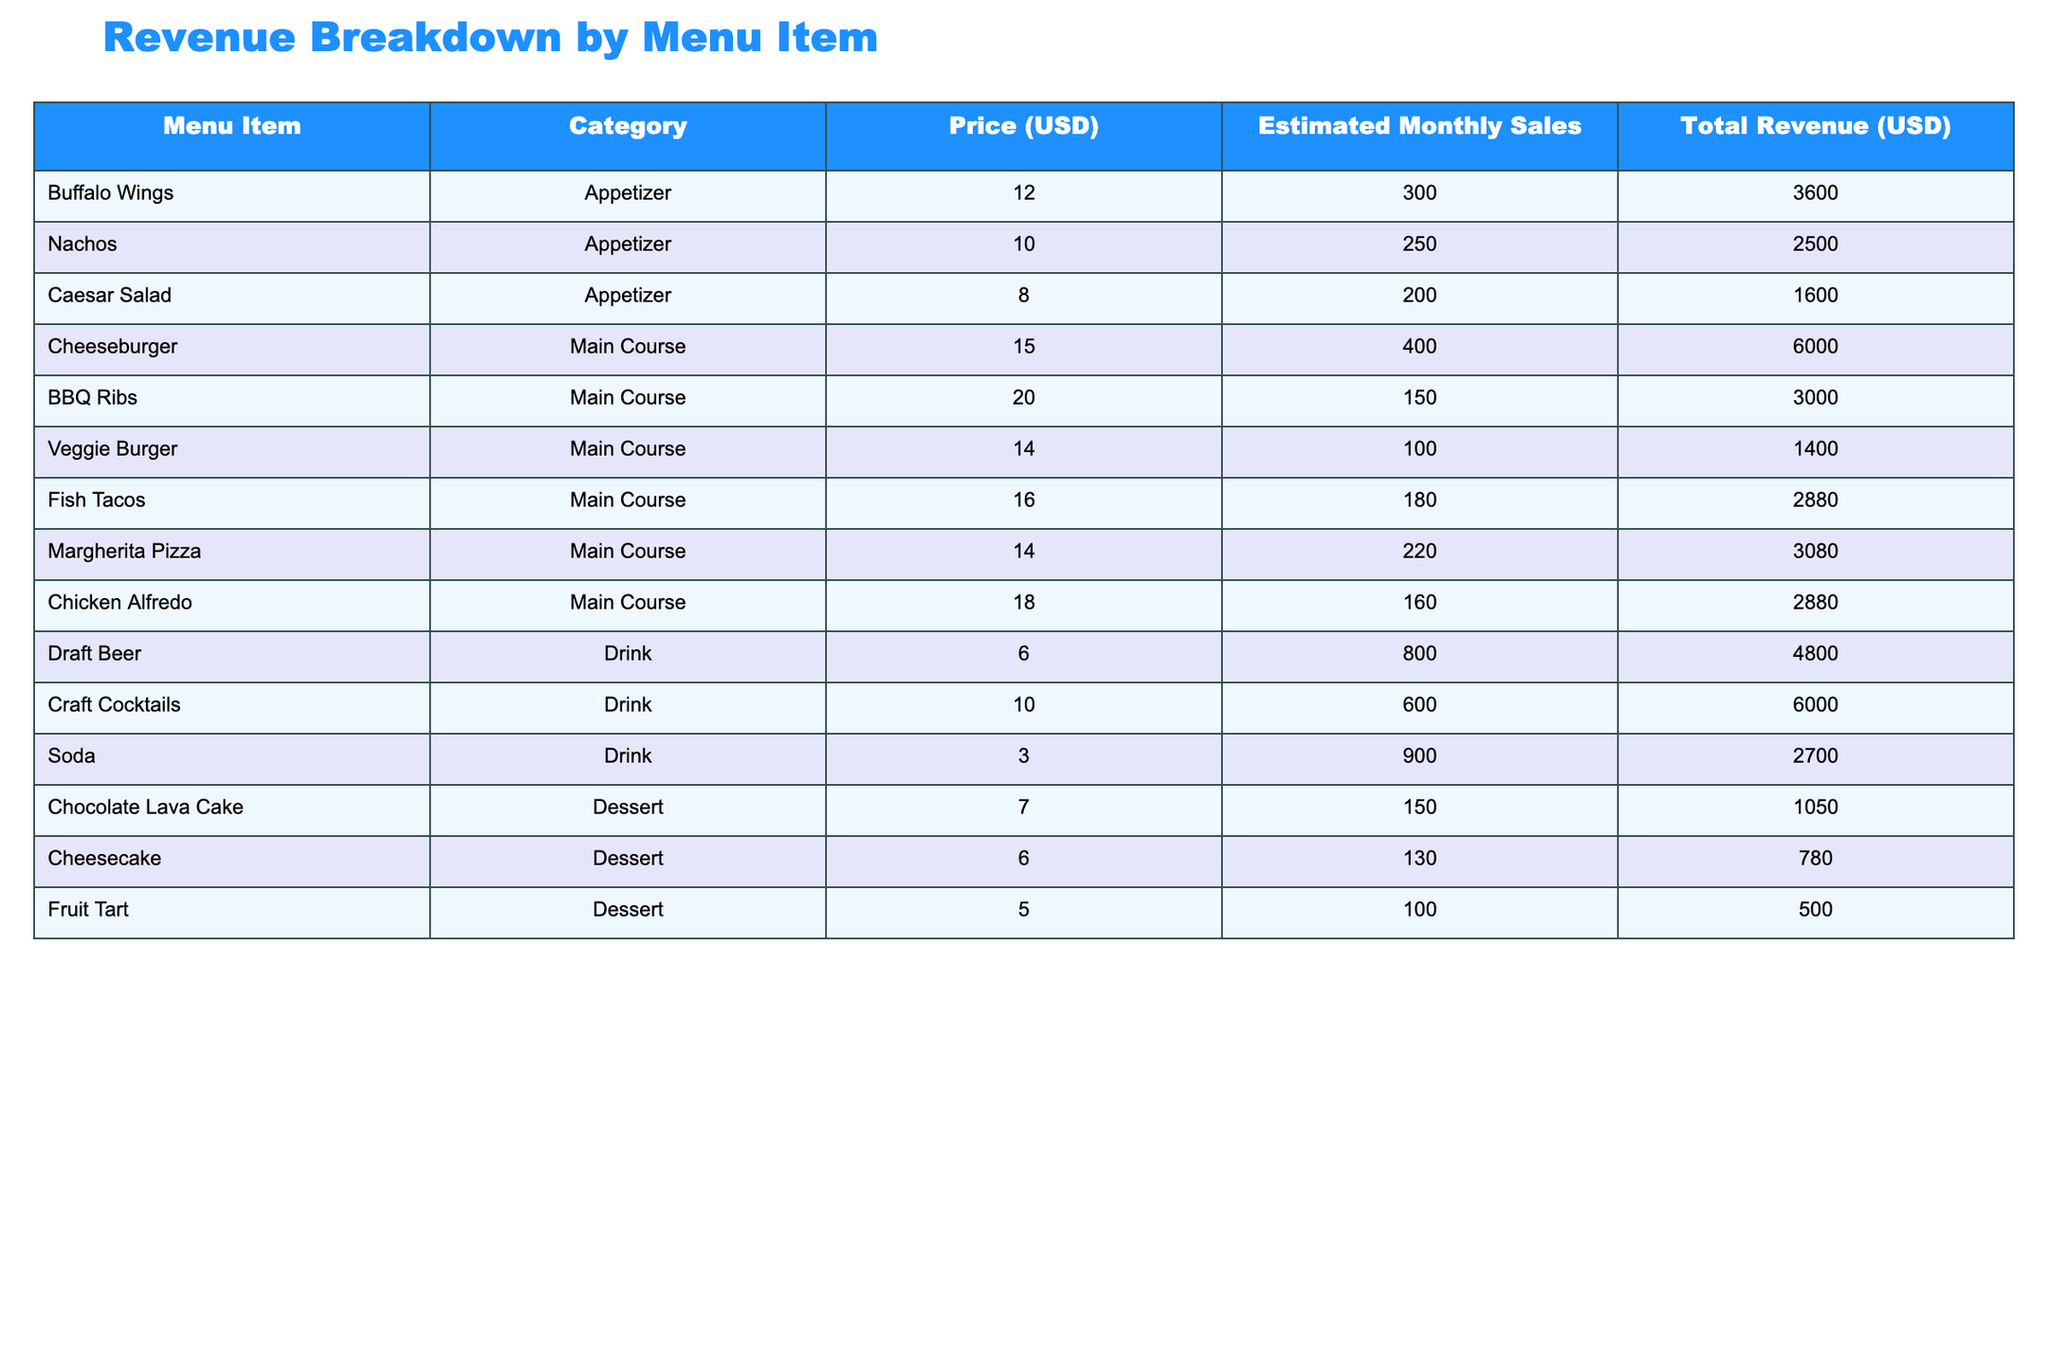What is the total revenue from Buffalo Wings? The total revenue for Buffalo Wings is listed directly in the table. The value is 3600 USD.
Answer: 3600 USD What is the category of the Fish Tacos? The Fish Tacos are classified under the "Main Course" category as indicated in the table.
Answer: Main Course Which menu item generated the highest revenue? To find the highest revenue, we compare all the total revenue values in the table. The Cheeseburger, with a total revenue of 6000 USD, has the highest value.
Answer: Cheeseburger What is the total revenue from all dessert menu items? We need to sum the total revenue for all dessert items. The values are 1050 (Chocolate Lava Cake) + 780 (Cheesecake) + 500 (Fruit Tart) = 2330.
Answer: 2330 USD Is the total revenue from Draft Beer greater than that from Nachos? Checking the total revenues, Draft Beer generated 4800 USD while Nachos generated 2500 USD. Therefore, the statement is true.
Answer: Yes What is the average price of the appetizers? To find the average price, we sum the prices of the appetizer items: 12 (Buffalo Wings) + 10 (Nachos) + 8 (Caesar Salad) = 30. Then, we divide by the number of appetizer items (3): 30/3 = 10.
Answer: 10 USD How much total revenue is generated from drinks? We sum up the total revenues from each drink: 4800 (Draft Beer) + 6000 (Craft Cocktails) + 2700 (Soda) = 13500.
Answer: 13500 USD What is the percentage of the total revenue that comes from the Main Course items compared to the entire menu? First, we need to sum the total revenue from the main course items. Those are: 6000 (Cheeseburger) + 3000 (BBQ Ribs) + 1400 (Veggie Burger) + 2880 (Fish Tacos) + 3080 (Margherita Pizza) + 2880 (Chicken Alfredo) = 18800. The entire revenue, which is the sum of all items, equals: 3600 (Buffalo Wings) + 2500 (Nachos) + 1600 (Caesar Salad) + 18800 (Main Course) + 4800 (Draft Beer) + 6000 (Craft Cocktails) + 2700 (Soda) + 1050 (Chocolate Lava Cake) + 780 (Cheesecake) + 500 (Fruit Tart) = 39230. To calculate the percentage, divide the main course revenue by total revenue: (18800/39230) * 100 ≈ 47.9%.
Answer: 47.9% Which item has the lowest sales among those listed? By examining the estimated monthly sales in the table, the Veggie Burger has the lowest sales, with a figure of 100.
Answer: Veggie Burger 